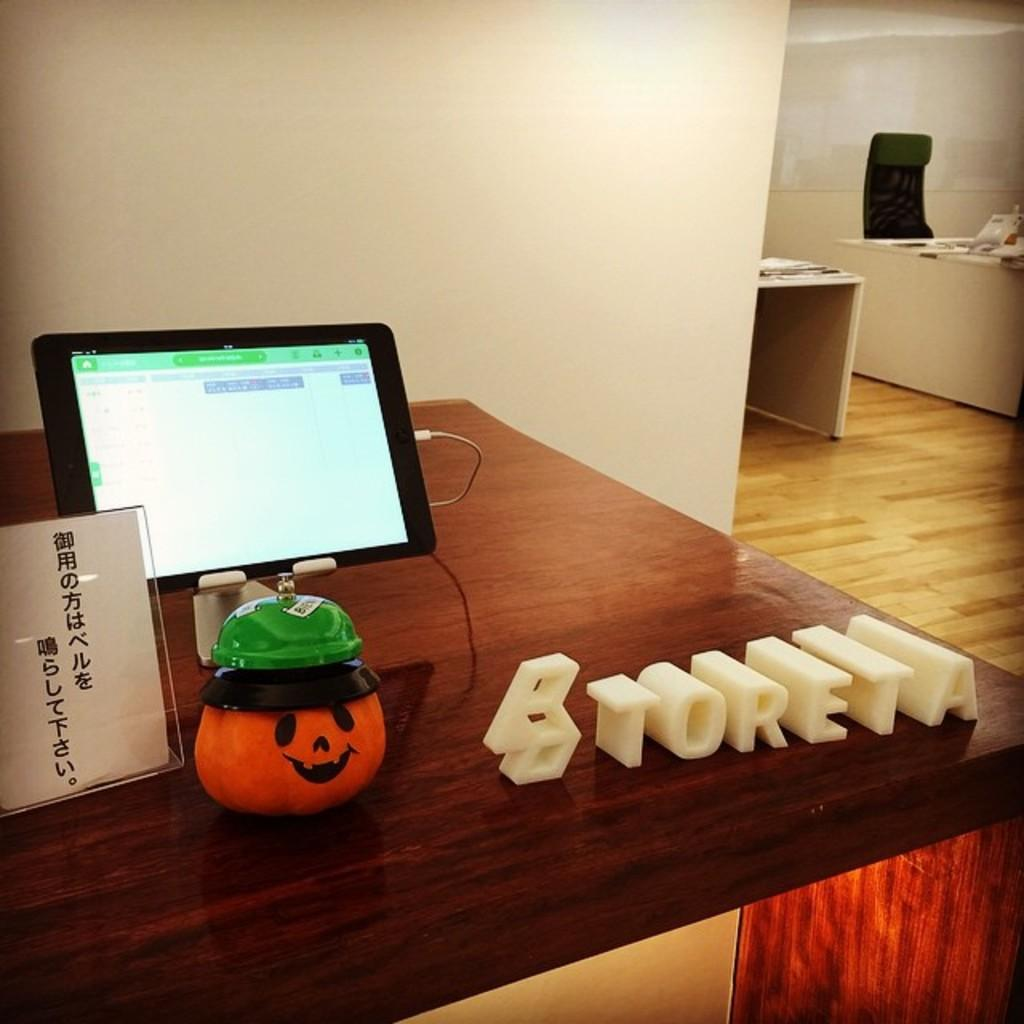What type of object is electronic in the image? There is an electronic gadget in the image. What other type of object is present in the image? There is a toy in the image. What is the nature of the paper with text in the image? The paper with text is a written document. On what surface are the objects placed in the image? The objects are placed on a surface. What color is the circle on the electronic gadget in the image? There is no circle present on the electronic gadget in the image. 